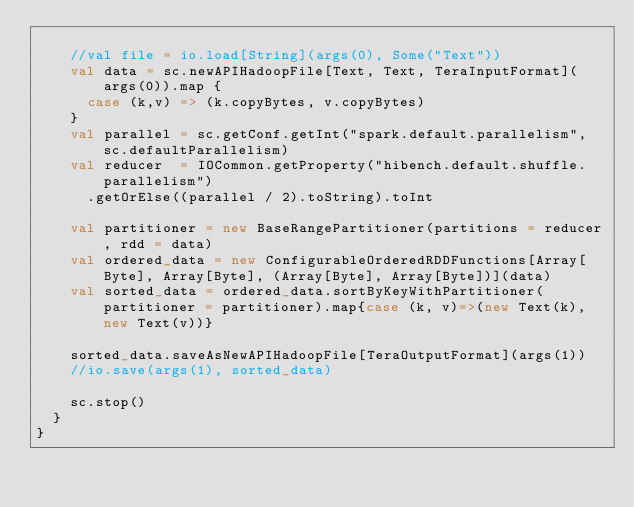<code> <loc_0><loc_0><loc_500><loc_500><_Scala_>
    //val file = io.load[String](args(0), Some("Text"))
    val data = sc.newAPIHadoopFile[Text, Text, TeraInputFormat](args(0)).map {
      case (k,v) => (k.copyBytes, v.copyBytes)
    }
    val parallel = sc.getConf.getInt("spark.default.parallelism", sc.defaultParallelism)
    val reducer  = IOCommon.getProperty("hibench.default.shuffle.parallelism")
      .getOrElse((parallel / 2).toString).toInt

    val partitioner = new BaseRangePartitioner(partitions = reducer, rdd = data)
    val ordered_data = new ConfigurableOrderedRDDFunctions[Array[Byte], Array[Byte], (Array[Byte], Array[Byte])](data)
    val sorted_data = ordered_data.sortByKeyWithPartitioner(partitioner = partitioner).map{case (k, v)=>(new Text(k), new Text(v))}

    sorted_data.saveAsNewAPIHadoopFile[TeraOutputFormat](args(1))
    //io.save(args(1), sorted_data)

    sc.stop()
  }
}
</code> 